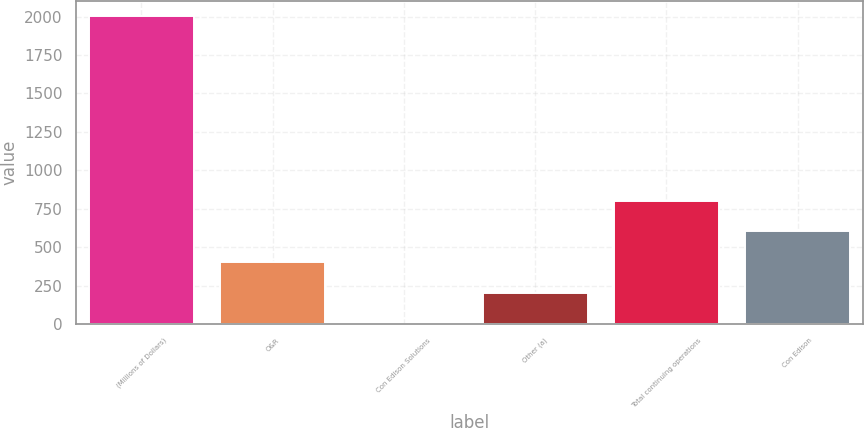<chart> <loc_0><loc_0><loc_500><loc_500><bar_chart><fcel>(Millions of Dollars)<fcel>O&R<fcel>Con Edison Solutions<fcel>Other (a)<fcel>Total continuing operations<fcel>Con Edison<nl><fcel>2004<fcel>403.2<fcel>3<fcel>203.1<fcel>803.4<fcel>603.3<nl></chart> 